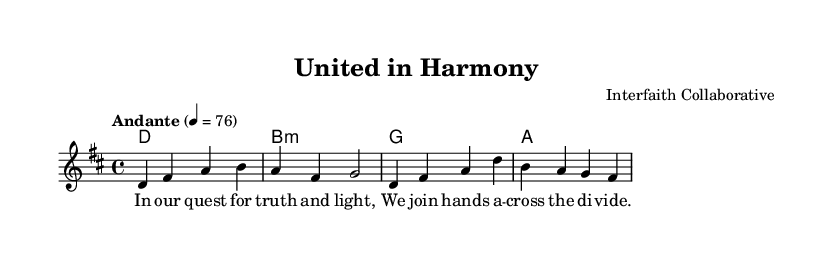What is the key signature of this music? The key signature shows two sharps, which indicates that the music is in D major.
Answer: D major What is the time signature of the piece? The time signature is displayed at the beginning of the score, which is 4/4. This means there are four beats in each measure and the quarter note gets one beat.
Answer: 4/4 What is the tempo marking for this piece? The tempo marking is indicated as "Andante," which is a term used to describe a moderate tempo. It is further specified that it should be played at a speed of 76 beats per minute.
Answer: Andante How many distinct sections are in the score? The score presents two main sections: the melody and the harmony, along with lyrics associated with the melody. This makes it straightforward to identify sections based on the layout.
Answer: Two What is the title of this piece? The title is clearly labeled at the beginning of the score, which is "United in Harmony." This is often a focal point when identifying the work.
Answer: United in Harmony What is the first lyric of the piece? The first lyric is associated with the melody line, and by inspecting the lyrics, it starts with the words "In our quest for truth and light." This gives a glimpse into the thematic essence of the piece.
Answer: In our quest for truth and light What type of chord is used in the second harmony? The second chord indicated in the harmony section is marked as B minor, which indicates a specific tonality and emotional quality. In chord mode notation, "b1:m" signifies a minor chord.
Answer: B minor 